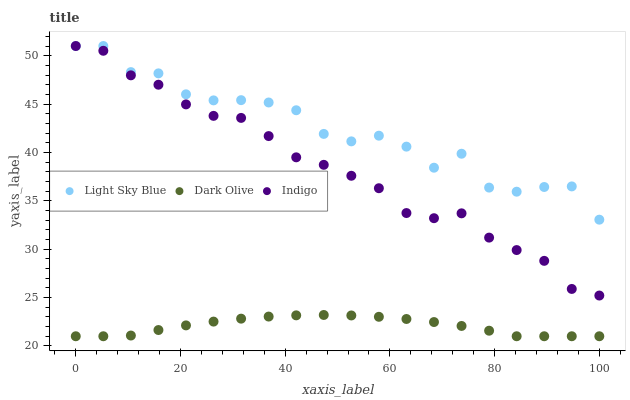Does Dark Olive have the minimum area under the curve?
Answer yes or no. Yes. Does Light Sky Blue have the maximum area under the curve?
Answer yes or no. Yes. Does Indigo have the minimum area under the curve?
Answer yes or no. No. Does Indigo have the maximum area under the curve?
Answer yes or no. No. Is Dark Olive the smoothest?
Answer yes or no. Yes. Is Light Sky Blue the roughest?
Answer yes or no. Yes. Is Indigo the smoothest?
Answer yes or no. No. Is Indigo the roughest?
Answer yes or no. No. Does Dark Olive have the lowest value?
Answer yes or no. Yes. Does Indigo have the lowest value?
Answer yes or no. No. Does Indigo have the highest value?
Answer yes or no. Yes. Is Dark Olive less than Indigo?
Answer yes or no. Yes. Is Light Sky Blue greater than Dark Olive?
Answer yes or no. Yes. Does Indigo intersect Light Sky Blue?
Answer yes or no. Yes. Is Indigo less than Light Sky Blue?
Answer yes or no. No. Is Indigo greater than Light Sky Blue?
Answer yes or no. No. Does Dark Olive intersect Indigo?
Answer yes or no. No. 